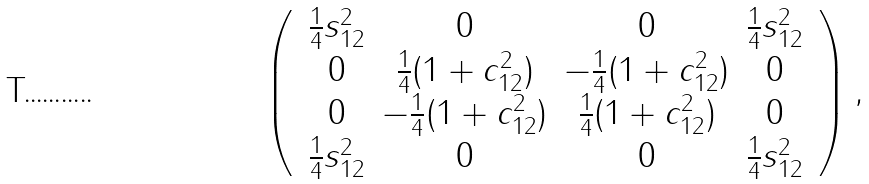<formula> <loc_0><loc_0><loc_500><loc_500>\left ( \, \begin{array} { c c c c } \frac { 1 } { 4 } s _ { 1 2 } ^ { 2 } & 0 & 0 & \frac { 1 } { 4 } s _ { 1 2 } ^ { 2 } \\ 0 & \frac { 1 } { 4 } ( 1 + c _ { 1 2 } ^ { 2 } ) & - \frac { 1 } { 4 } ( 1 + c _ { 1 2 } ^ { 2 } ) & 0 \\ 0 & - \frac { 1 } { 4 } ( 1 + c _ { 1 2 } ^ { 2 } ) & \frac { 1 } { 4 } ( 1 + c _ { 1 2 } ^ { 2 } ) & 0 \\ \frac { 1 } { 4 } s _ { 1 2 } ^ { 2 } & 0 & 0 & \frac { 1 } { 4 } s _ { 1 2 } ^ { 2 } \\ \end{array} \, \right ) , \\</formula> 